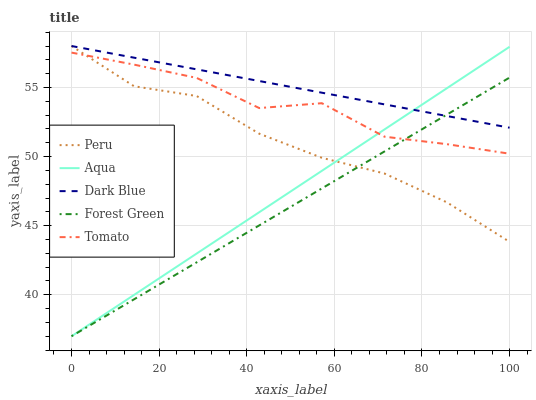Does Dark Blue have the minimum area under the curve?
Answer yes or no. No. Does Forest Green have the maximum area under the curve?
Answer yes or no. No. Is Dark Blue the smoothest?
Answer yes or no. No. Is Dark Blue the roughest?
Answer yes or no. No. Does Dark Blue have the lowest value?
Answer yes or no. No. Does Forest Green have the highest value?
Answer yes or no. No. Is Tomato less than Dark Blue?
Answer yes or no. Yes. Is Dark Blue greater than Tomato?
Answer yes or no. Yes. Does Tomato intersect Dark Blue?
Answer yes or no. No. 